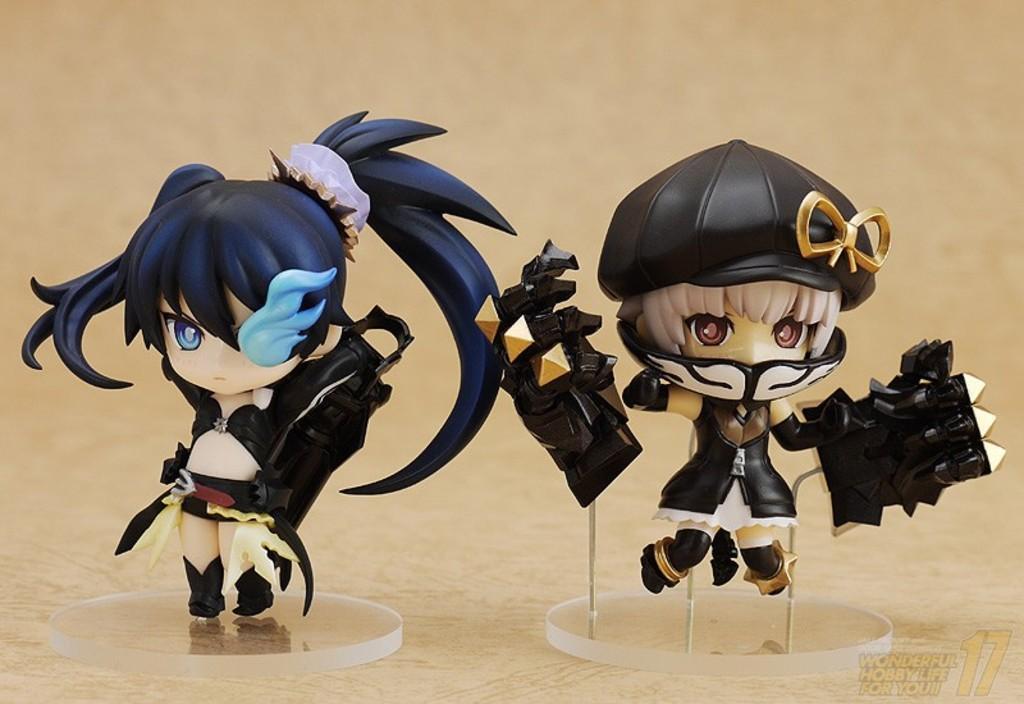Can you describe this image briefly? In this image there are toys on the wooden surface. At the bottom right side of the image there is a watermark. In the background of the image it is blurry. 